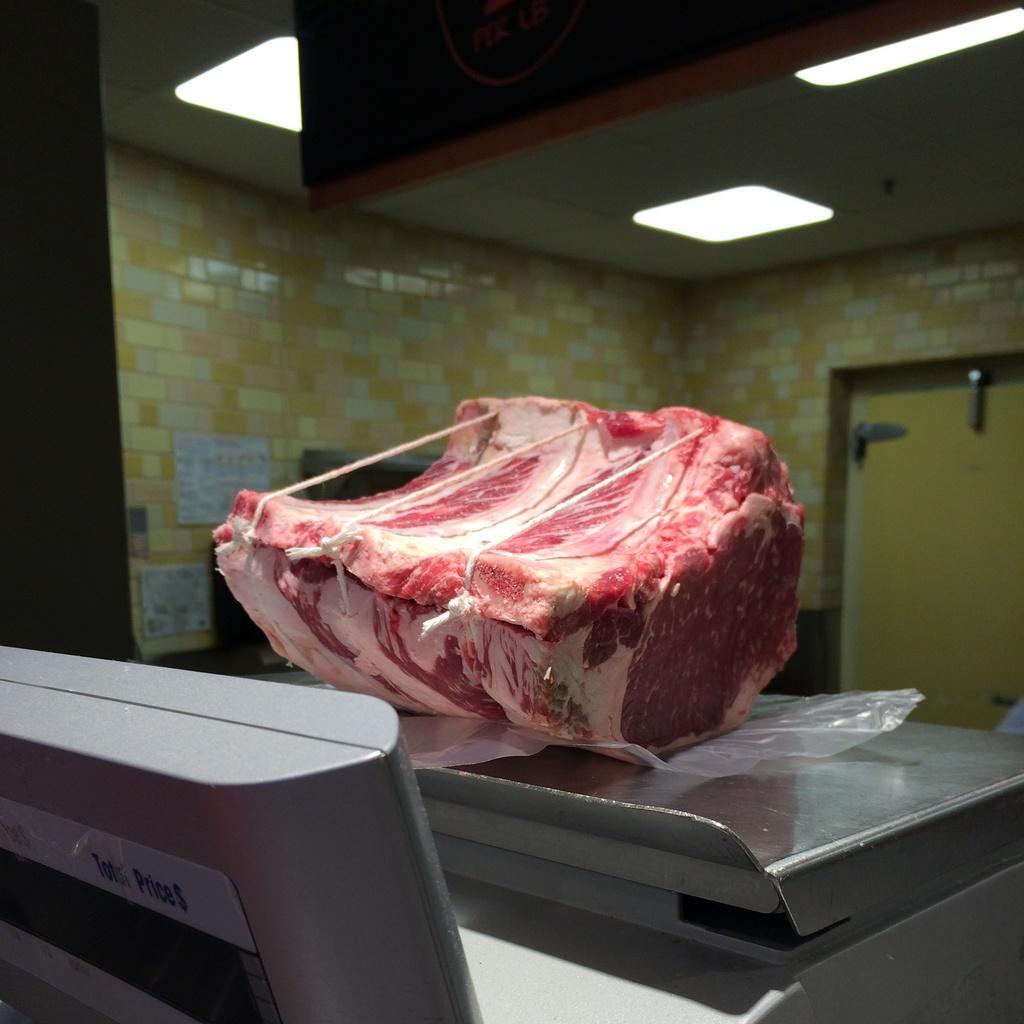Can you describe this image briefly? In the center of the image, we can see a meat on the weighing machine and in the background, there is a door and a wall. 